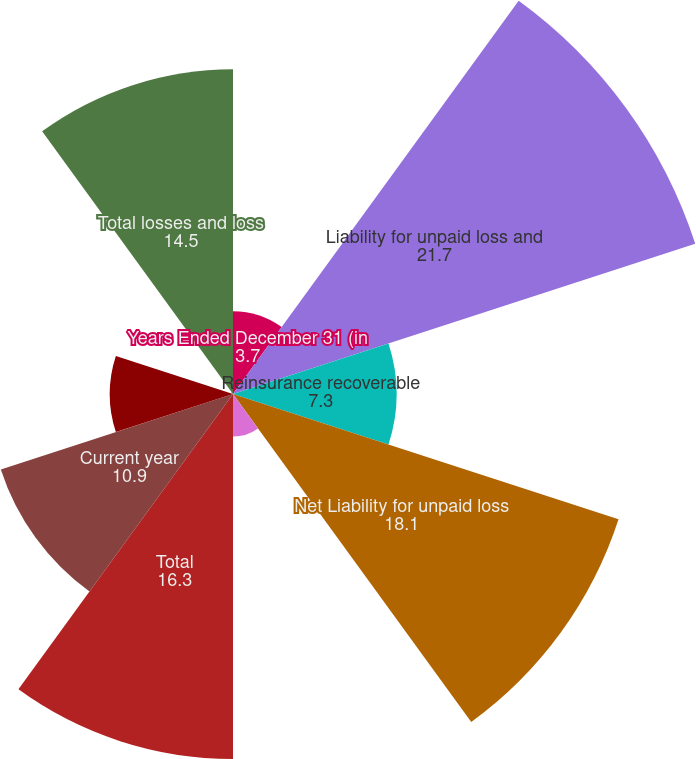<chart> <loc_0><loc_0><loc_500><loc_500><pie_chart><fcel>Years Ended December 31 (in<fcel>Liability for unpaid loss and<fcel>Reinsurance recoverable<fcel>Net Liability for unpaid loss<fcel>Foreign exchange effect<fcel>Total<fcel>Current year<fcel>Prior years excluding discount<fcel>Prior years discount charge<fcel>Total losses and loss<nl><fcel>3.7%<fcel>21.7%<fcel>7.3%<fcel>18.1%<fcel>1.9%<fcel>16.3%<fcel>10.9%<fcel>5.5%<fcel>0.1%<fcel>14.5%<nl></chart> 